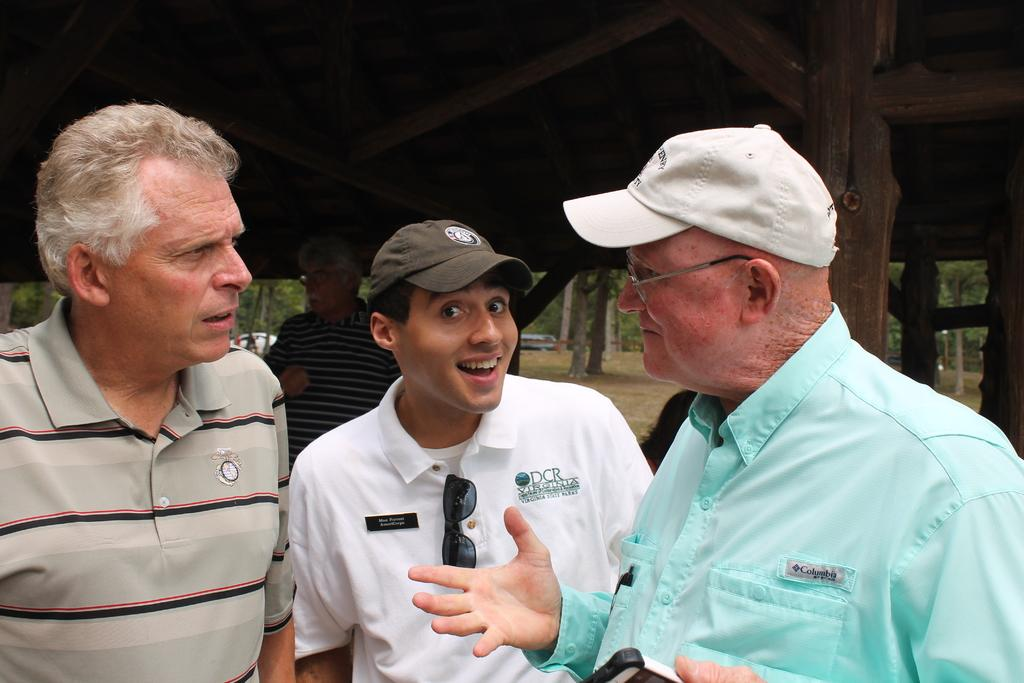How many people are in the image? There are people in the image, but the exact number is not specified. What are two people wearing in the image? Two people are wearing caps in the image. What type of structure can be seen in the image? There is a shed in the image. What can be seen in the background of the image? There are trees and vehicles visible in the background of the image. What type of finger can be seen pointing at the shed in the image? There is no finger pointing at the shed in the image. Is there a cemetery visible in the image? No, there is no cemetery present in the image. 